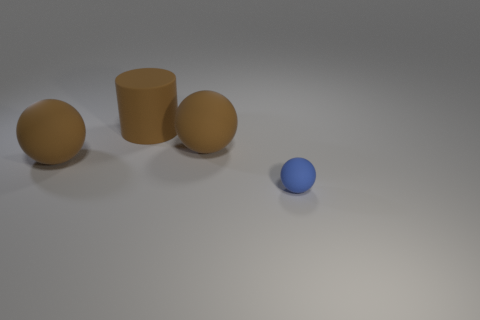What number of things are either brown balls on the right side of the large rubber cylinder or small gray rubber things?
Offer a terse response. 1. What size is the brown cylinder?
Make the answer very short. Large. Is the size of the brown object left of the brown rubber cylinder the same as the tiny thing?
Provide a succinct answer. No. Is there a big rubber ball that has the same color as the matte cylinder?
Offer a very short reply. Yes. What number of things are balls that are behind the tiny blue matte ball or objects left of the tiny rubber sphere?
Your response must be concise. 3. Does the tiny matte object have the same color as the large rubber cylinder?
Your answer should be very brief. No. Are there fewer tiny matte objects that are left of the small thing than brown spheres that are to the left of the rubber cylinder?
Offer a terse response. Yes. Is the blue object made of the same material as the brown cylinder?
Provide a short and direct response. Yes. There is a matte object that is both right of the large cylinder and behind the small blue rubber sphere; what is its size?
Provide a succinct answer. Large. There is a big brown object in front of the large brown sphere to the right of the large matte sphere on the left side of the brown cylinder; what is its material?
Make the answer very short. Rubber. 